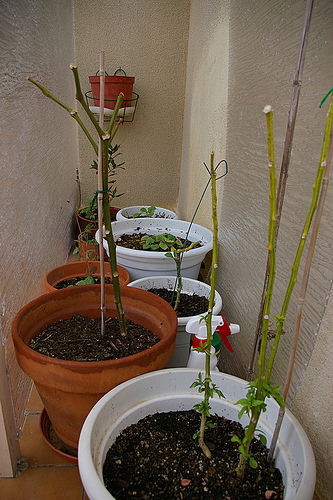<image>
Can you confirm if the dirt is in the pot? Yes. The dirt is contained within or inside the pot, showing a containment relationship. 